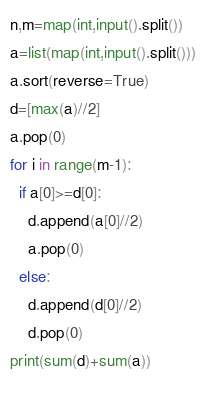Convert code to text. <code><loc_0><loc_0><loc_500><loc_500><_Python_>n,m=map(int,input().split())
a=list(map(int,input().split()))
a.sort(reverse=True)
d=[max(a)//2]
a.pop(0)
for i in range(m-1):
  if a[0]>=d[0]:
    d.append(a[0]//2)
    a.pop(0)
  else:
    d.append(d[0]//2)
    d.pop(0)
print(sum(d)+sum(a))
    </code> 